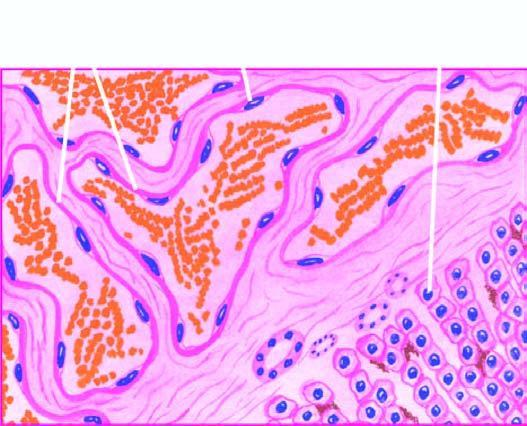s scanty connective tissue stroma seen between the cavernous spaces?
Answer the question using a single word or phrase. Yes 